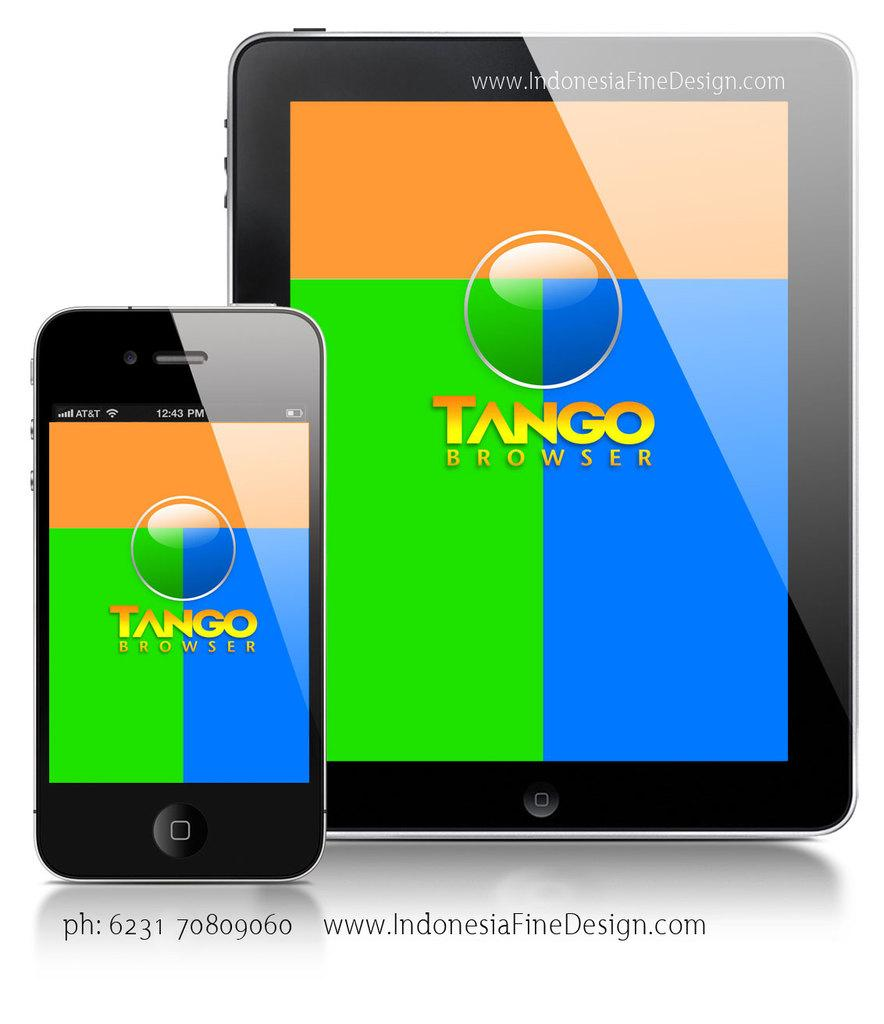<image>
Summarize the visual content of the image. An iPad and Iphone with Tango Browser on their displays. 